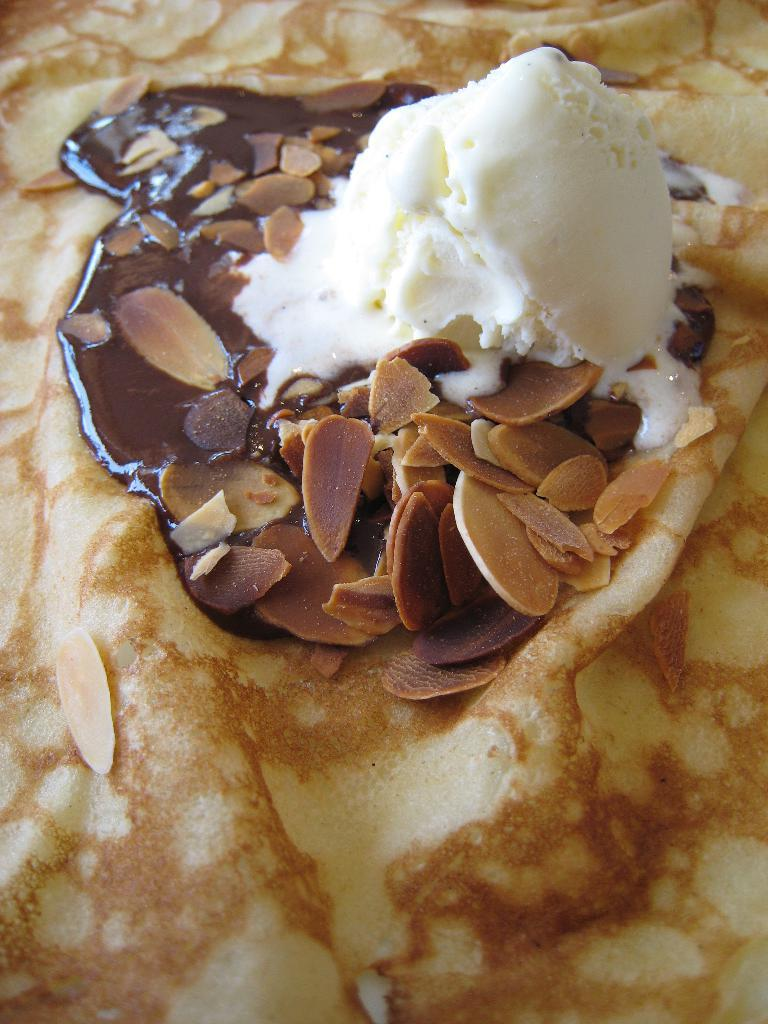What can be seen in the image? There is food visible in the image. What type of apparatus is used to create the bead patterns on the card in the image? There is no apparatus, bead, or card present in the image; it only features food. 